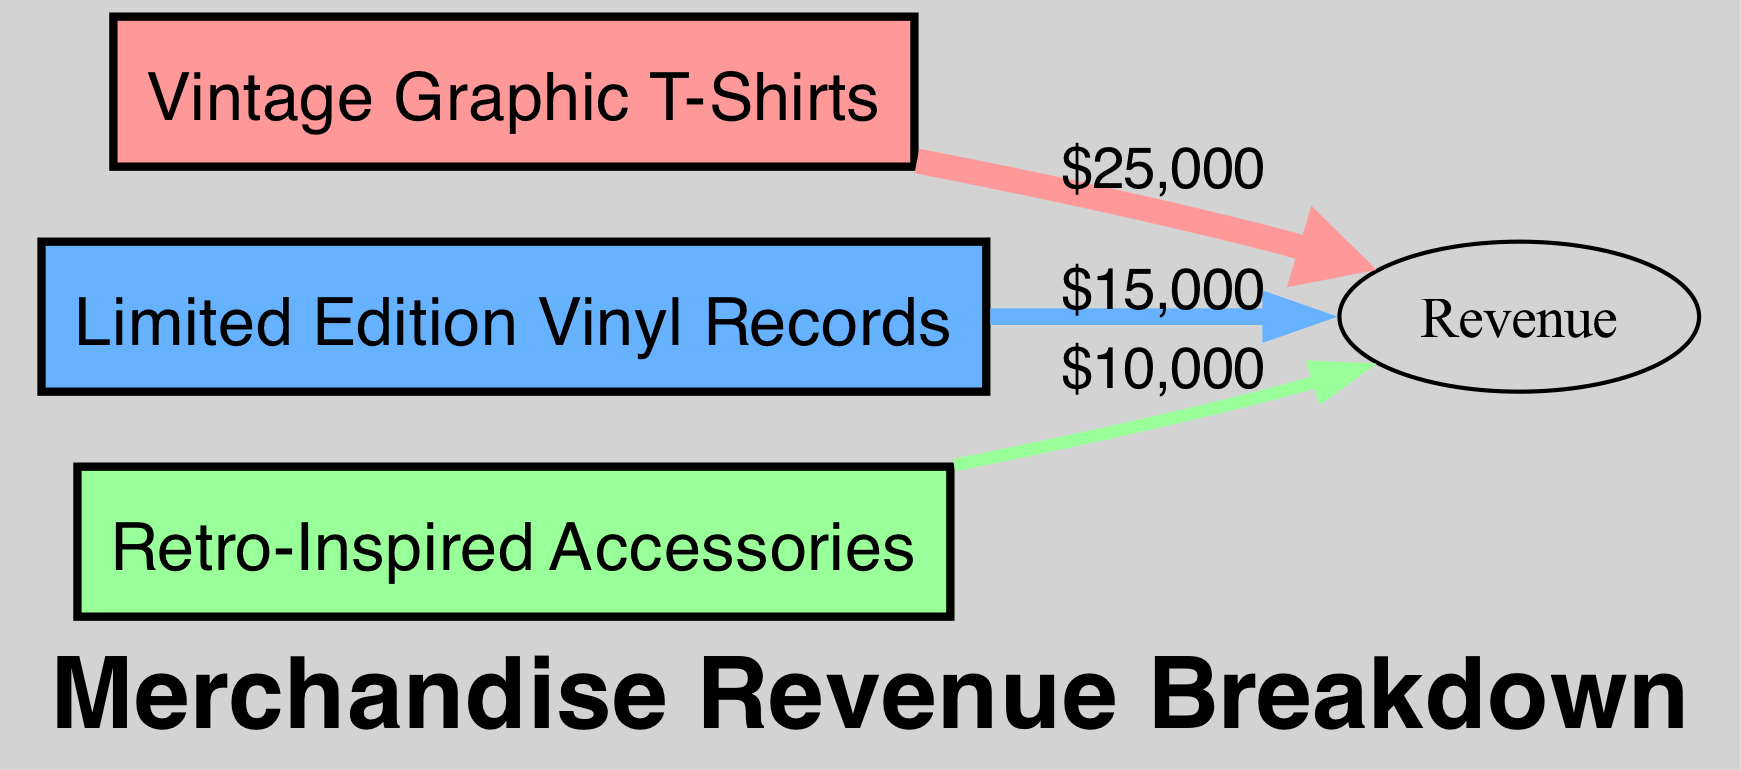What is the total merchandise revenue? To find the total merchandise revenue, we sum the values of all the links to the 'Revenue' target node. The values are $25,000 for T-Shirts, $15,000 for Vinyls, and $10,000 for Accessories. Therefore, the total is $25,000 + $15,000 + $10,000 = $50,000.
Answer: $50,000 Which item generated the highest revenue? By examining the links, T-Shirts show a revenue of $25,000, which is greater than the $15,000 from Vinyls and $10,000 from Accessories. Therefore, T-Shirts generated the highest revenue.
Answer: T-Shirts What is the revenue from Accessories? The link from Accessories to Revenue shows a value of $10,000, indicating that this is the total revenue generated by Accessories during the tour.
Answer: $10,000 How many different merchandise items are represented in the diagram? The diagram includes three nodes, representing Vintage Graphic T-Shirts, Limited Edition Vinyl Records, and Retro-Inspired Accessories. Therefore, there are three different merchandise items represented.
Answer: 3 What percentage of the total revenue is generated by Vinyls? To find the percentage, we compare Vinyls' revenue of $15,000 to the total revenue of $50,000. The calculation is ($15,000 / $50,000) * 100, which equals 30%.
Answer: 30% 